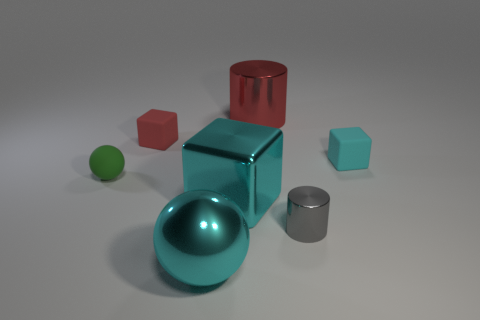What color is the small matte block that is in front of the rubber block left of the big metal object that is in front of the small cylinder?
Your answer should be very brief. Cyan. There is a small cyan rubber object; is its shape the same as the shiny object that is behind the small ball?
Your answer should be compact. No. There is a rubber object that is both left of the big cyan block and behind the small green matte object; what is its color?
Ensure brevity in your answer.  Red. Is there a tiny yellow object of the same shape as the red shiny object?
Give a very brief answer. No. Is the large cylinder the same color as the large ball?
Keep it short and to the point. No. Are there any green matte objects behind the shiny cylinder that is in front of the small cyan block?
Offer a terse response. Yes. How many objects are either matte things to the right of the small green ball or rubber things that are in front of the tiny red object?
Offer a very short reply. 3. What number of things are either big balls or metal objects that are to the left of the small gray shiny thing?
Provide a succinct answer. 3. There is a shiny cylinder behind the small gray object in front of the cyan block that is in front of the tiny green object; what is its size?
Offer a very short reply. Large. What material is the red object that is the same size as the cyan shiny block?
Your response must be concise. Metal. 